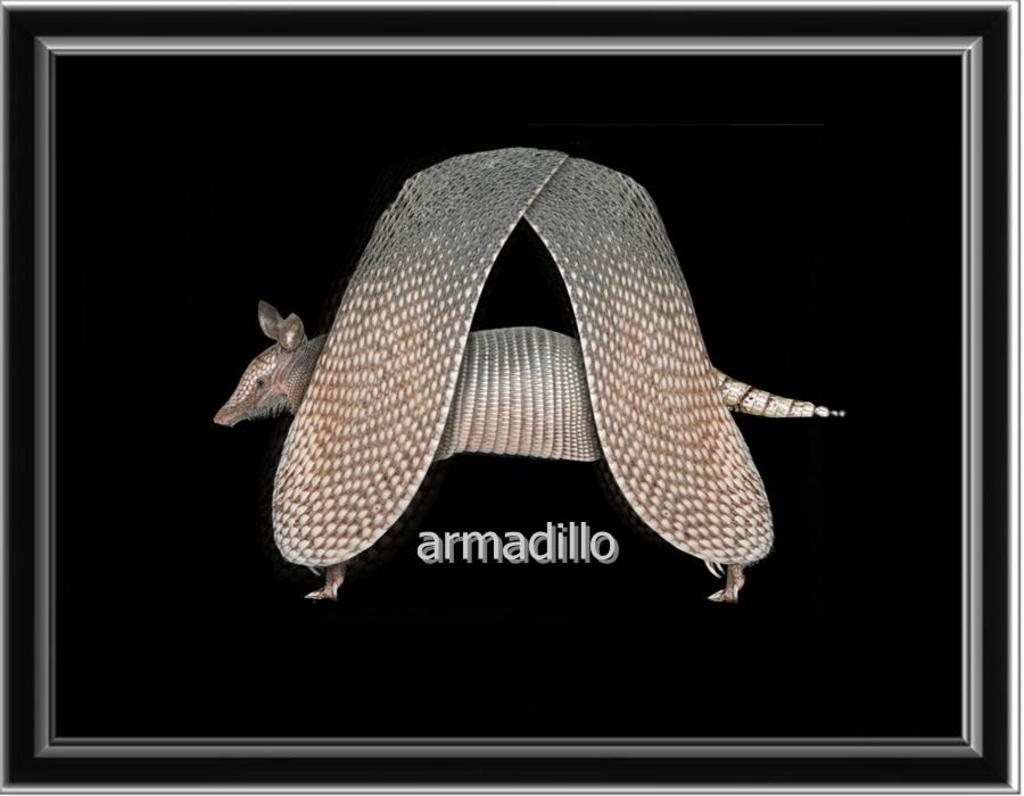What object in the image typically holds a picture or photograph? There is a photo frame in the image. What type of living creature can be seen in the image? There is an animal in the image. What type of fog can be seen surrounding the animal in the image? There is no fog present in the image; it only features a photo frame and an animal. How many boys are visible in the image? There are no boys present in the image. 